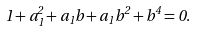<formula> <loc_0><loc_0><loc_500><loc_500>1 + a _ { 1 } ^ { 2 } + a _ { 1 } b + a _ { 1 } b ^ { 2 } + b ^ { 4 } = 0 .</formula> 